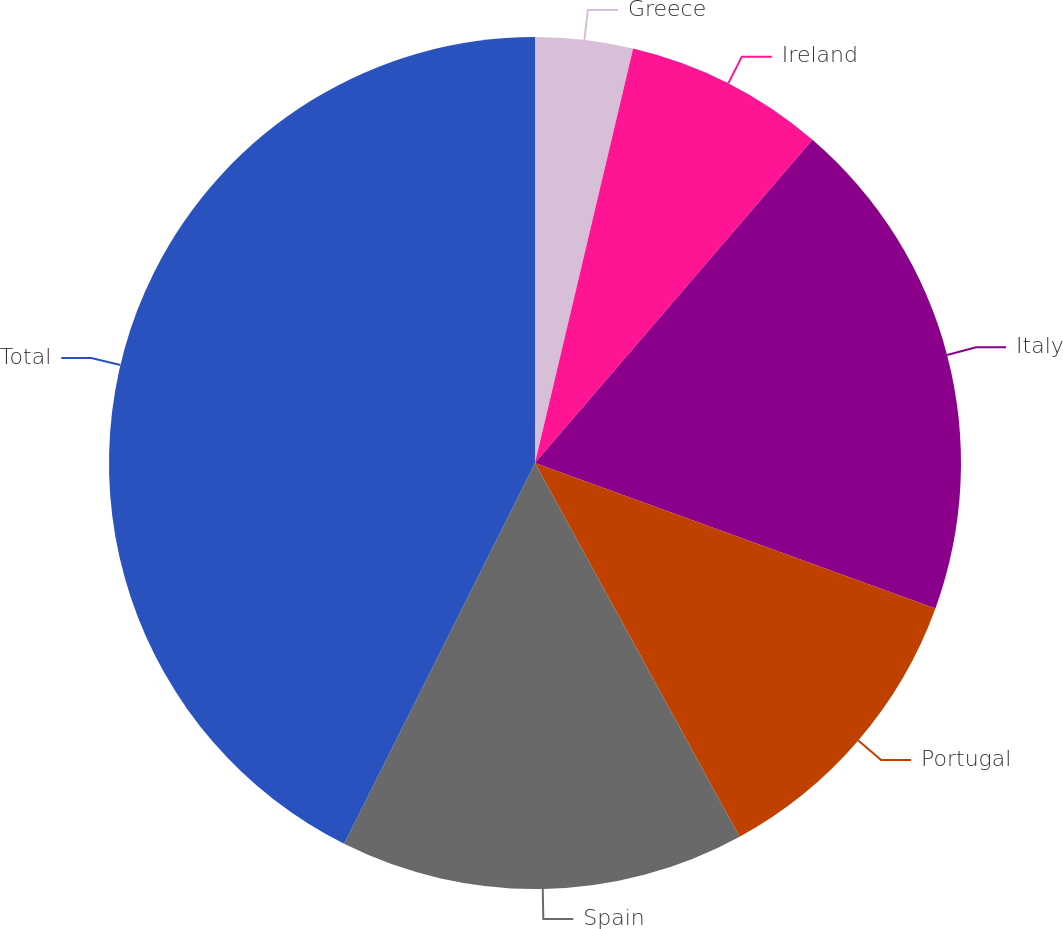<chart> <loc_0><loc_0><loc_500><loc_500><pie_chart><fcel>Greece<fcel>Ireland<fcel>Italy<fcel>Portugal<fcel>Spain<fcel>Total<nl><fcel>3.7%<fcel>7.59%<fcel>19.26%<fcel>11.48%<fcel>15.37%<fcel>42.61%<nl></chart> 